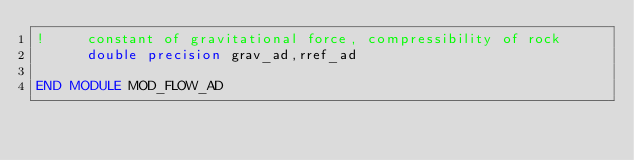<code> <loc_0><loc_0><loc_500><loc_500><_FORTRAN_>!     constant of gravitational force, compressibility of rock
      double precision grav_ad,rref_ad

END MODULE MOD_FLOW_AD
</code> 